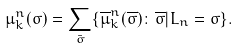Convert formula to latex. <formula><loc_0><loc_0><loc_500><loc_500>\mu _ { k } ^ { n } ( \sigma ) = \sum _ { \bar { \sigma } } \{ \overline { \mu } _ { k } ^ { n } ( { \overline { \sigma } } ) \colon \overline { \sigma } | L _ { n } = \sigma \} .</formula> 